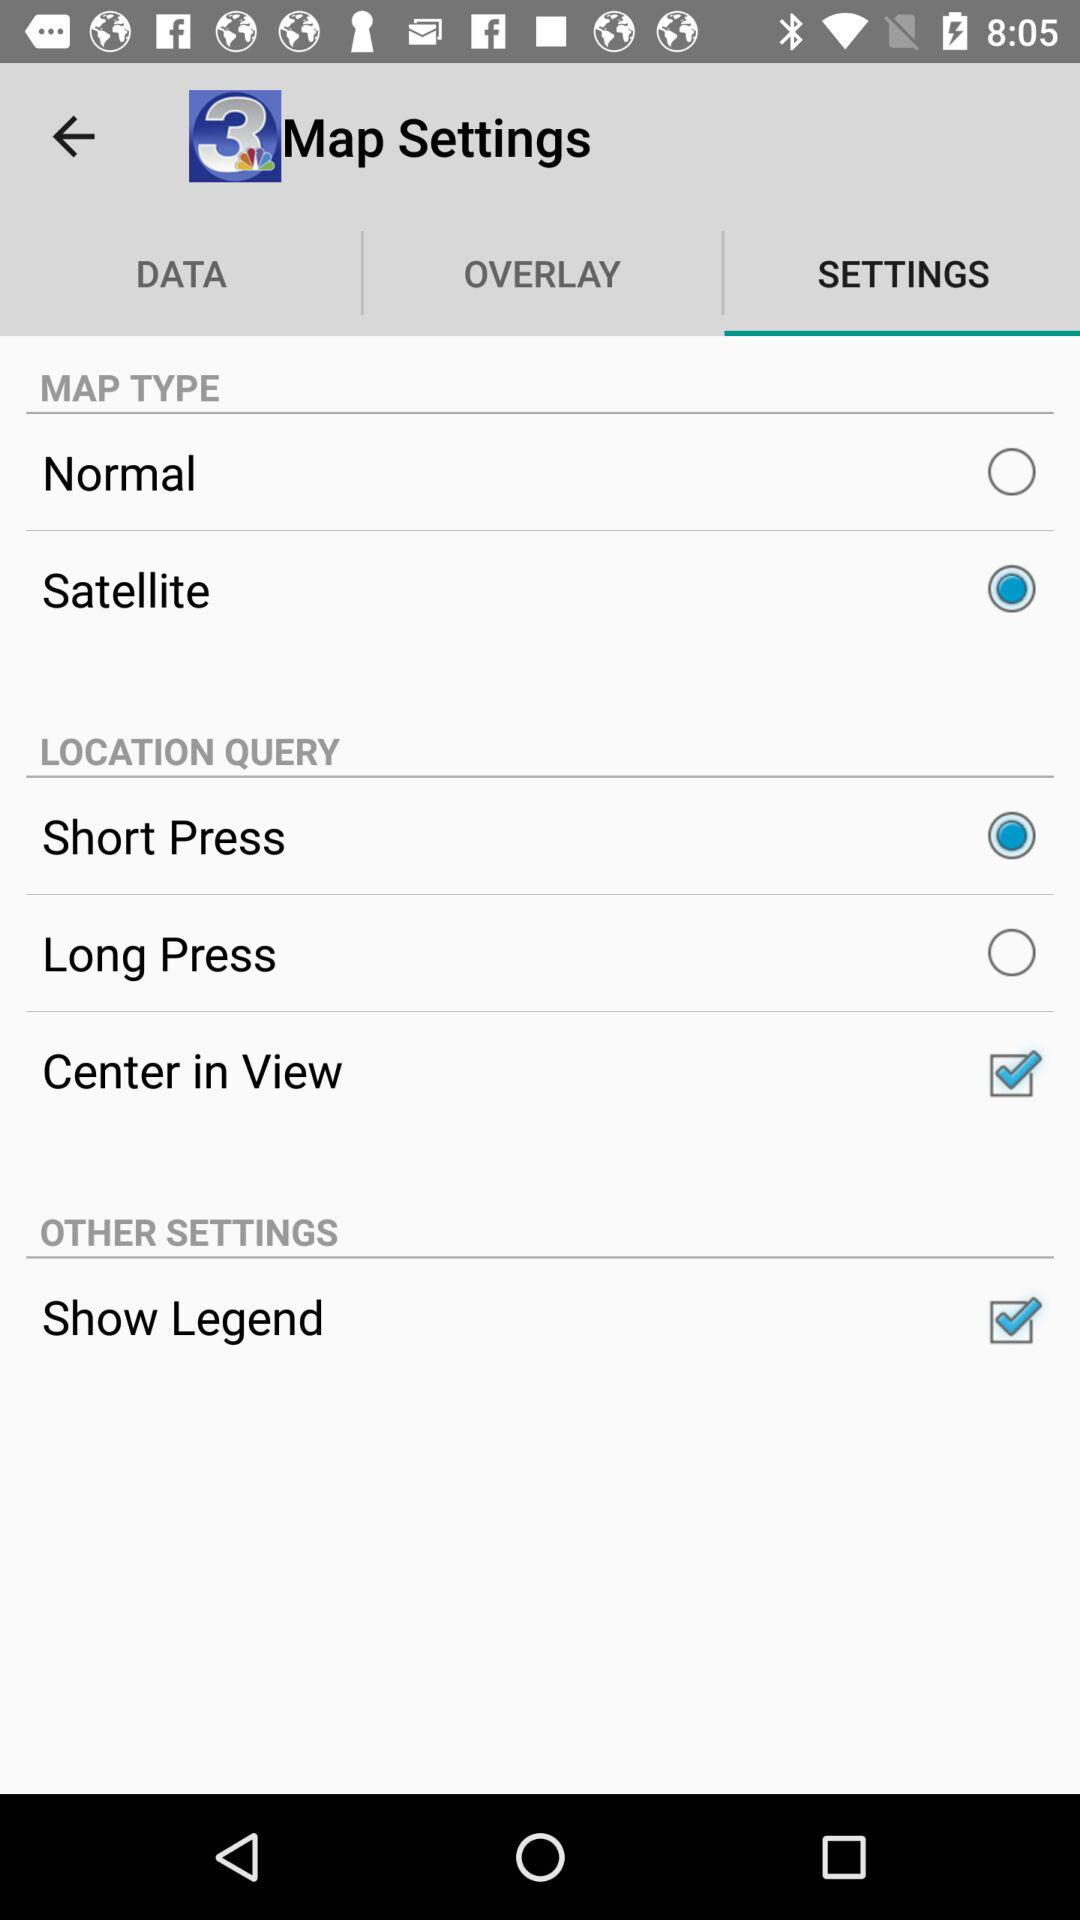Which press option is selected in "LOCATION QUERY"? The selected press option in "LOCATION QUERY" is "Short Press". 